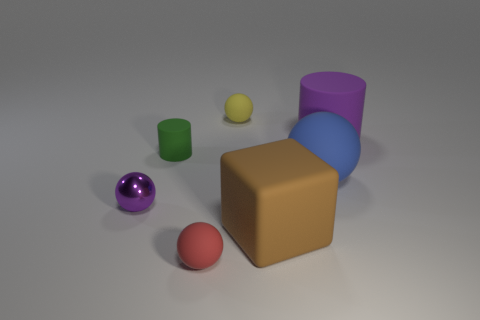Subtract all tiny purple spheres. How many spheres are left? 3 Add 2 green rubber cylinders. How many objects exist? 9 Subtract all green cylinders. How many cylinders are left? 1 Subtract all balls. How many objects are left? 3 Add 1 purple cylinders. How many purple cylinders are left? 2 Add 4 small cylinders. How many small cylinders exist? 5 Subtract 0 blue cubes. How many objects are left? 7 Subtract 1 blocks. How many blocks are left? 0 Subtract all green cylinders. Subtract all cyan spheres. How many cylinders are left? 1 Subtract all purple blocks. How many purple cylinders are left? 1 